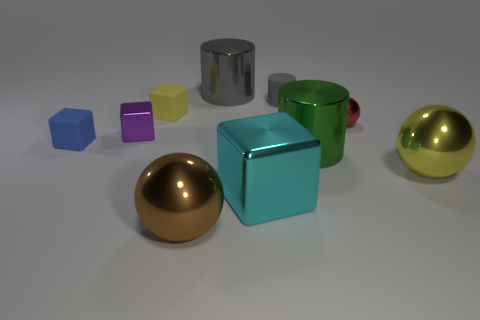Subtract all big cylinders. How many cylinders are left? 1 Subtract all yellow cubes. How many cubes are left? 3 Subtract all spheres. How many objects are left? 7 Subtract 1 cubes. How many cubes are left? 3 Subtract all cyan cubes. Subtract all cyan balls. How many cubes are left? 3 Subtract all red spheres. How many brown cubes are left? 0 Subtract all big cyan things. Subtract all large yellow metallic objects. How many objects are left? 8 Add 3 small blue objects. How many small blue objects are left? 4 Add 7 cyan metallic cylinders. How many cyan metallic cylinders exist? 7 Subtract 0 purple cylinders. How many objects are left? 10 